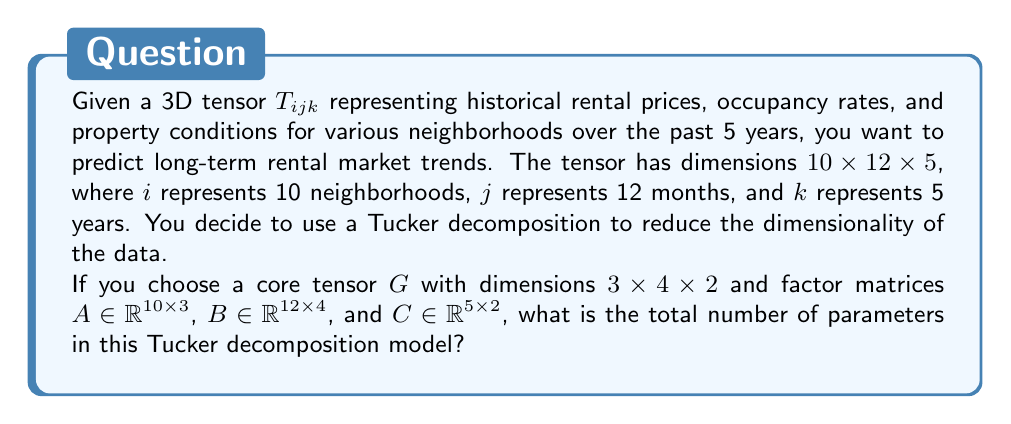Help me with this question. To solve this problem, we need to calculate the number of parameters in the Tucker decomposition model. The Tucker decomposition of a 3D tensor $T_{ijk}$ can be expressed as:

$$T_{ijk} \approx \sum_{p=1}^{P} \sum_{q=1}^{Q} \sum_{r=1}^{R} g_{pqr} a_{ip} b_{jq} c_{kr}$$

where $G = (g_{pqr})$ is the core tensor, and $A = (a_{ip})$, $B = (b_{jq})$, and $C = (c_{kr})$ are the factor matrices.

Let's count the parameters:

1. Core tensor $G$: It has dimensions $3 \times 4 \times 2$
   Number of parameters in $G = 3 \times 4 \times 2 = 24$

2. Factor matrix $A$: It has dimensions $10 \times 3$
   Number of parameters in $A = 10 \times 3 = 30$

3. Factor matrix $B$: It has dimensions $12 \times 4$
   Number of parameters in $B = 12 \times 4 = 48$

4. Factor matrix $C$: It has dimensions $5 \times 2$
   Number of parameters in $C = 5 \times 2 = 10$

The total number of parameters is the sum of parameters in $G$, $A$, $B$, and $C$:

Total parameters $= 24 + 30 + 48 + 10 = 112$
Answer: 112 parameters 